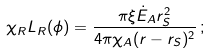Convert formula to latex. <formula><loc_0><loc_0><loc_500><loc_500>\chi _ { R } L _ { R } ( \phi ) = \frac { \pi \xi \dot { E } _ { A } r _ { S } ^ { 2 } } { 4 \pi \chi _ { A } ( r - r _ { S } ) ^ { 2 } } \, ;</formula> 